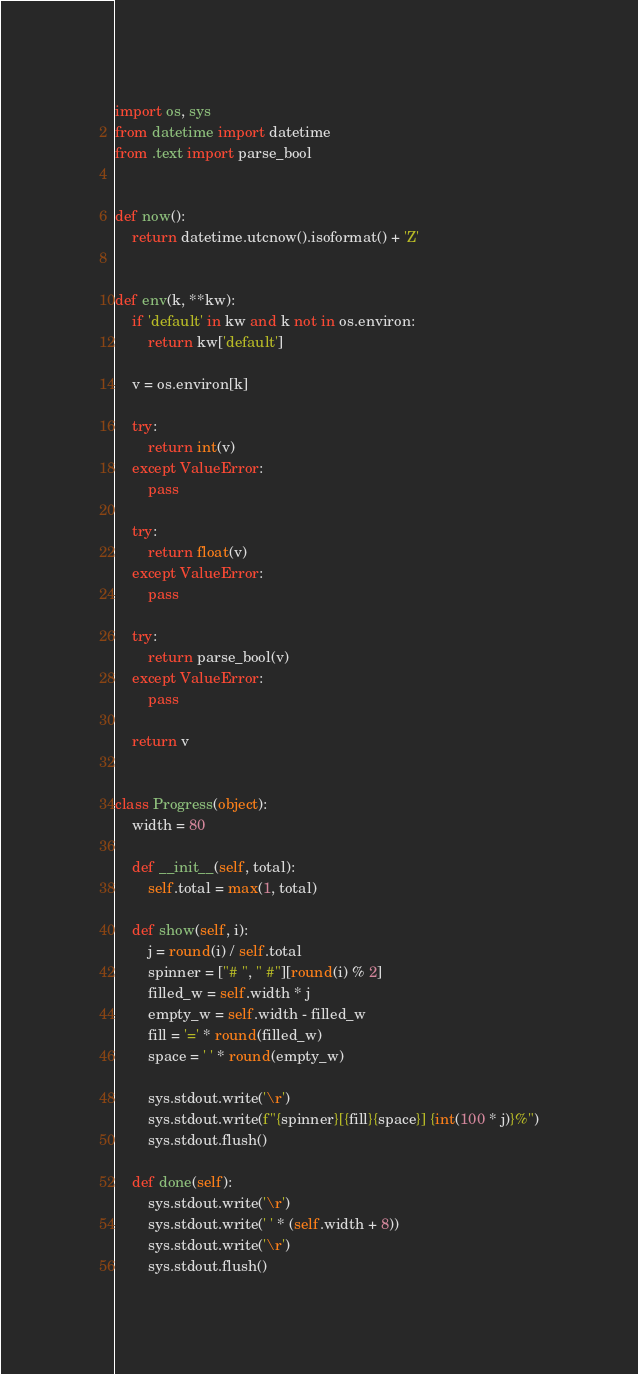Convert code to text. <code><loc_0><loc_0><loc_500><loc_500><_Python_>import os, sys
from datetime import datetime
from .text import parse_bool


def now():
    return datetime.utcnow().isoformat() + 'Z'


def env(k, **kw):
    if 'default' in kw and k not in os.environ:
        return kw['default']

    v = os.environ[k]

    try:
        return int(v)
    except ValueError:
        pass

    try:
        return float(v)
    except ValueError:
        pass

    try:
        return parse_bool(v)
    except ValueError:
        pass

    return v


class Progress(object):
    width = 80

    def __init__(self, total):
        self.total = max(1, total)

    def show(self, i):
        j = round(i) / self.total
        spinner = ["# ", " #"][round(i) % 2]
        filled_w = self.width * j
        empty_w = self.width - filled_w
        fill = '=' * round(filled_w)
        space = ' ' * round(empty_w)

        sys.stdout.write('\r')
        sys.stdout.write(f"{spinner}[{fill}{space}] {int(100 * j)}%")
        sys.stdout.flush()

    def done(self):
        sys.stdout.write('\r')
        sys.stdout.write(' ' * (self.width + 8))
        sys.stdout.write('\r')
        sys.stdout.flush()
</code> 